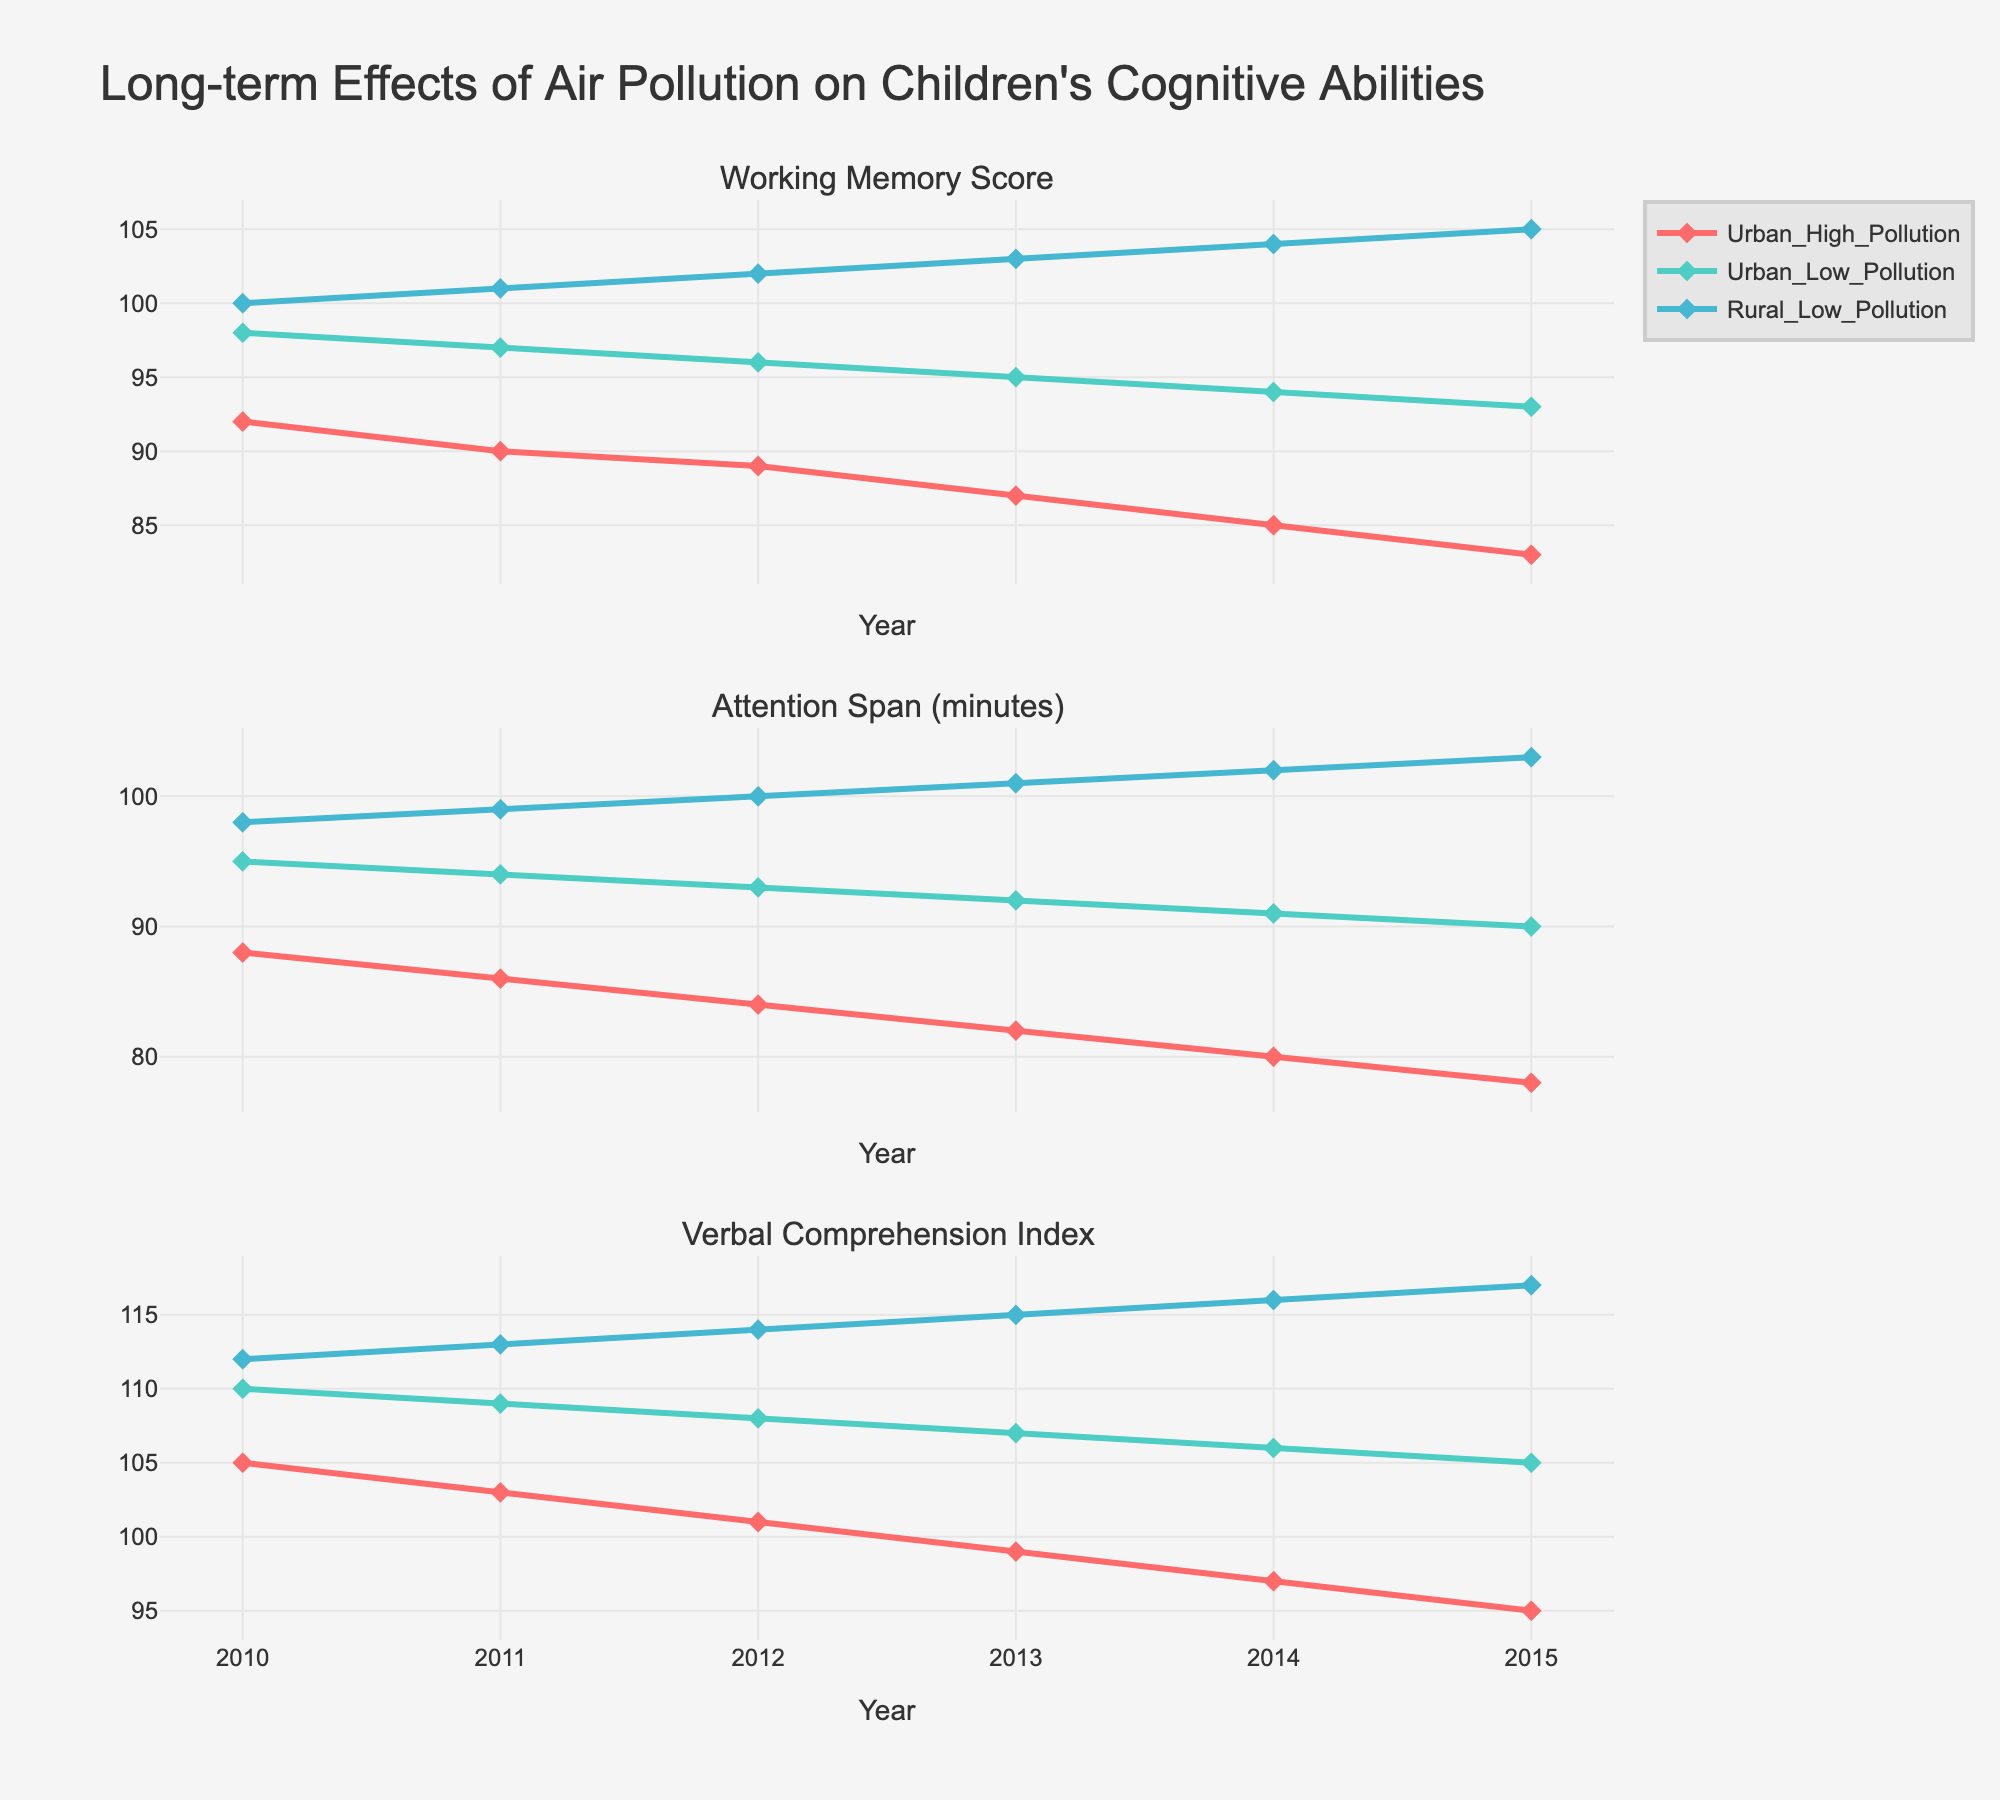What is the difference in the Working Memory Score for Urban High Pollution and Rural Low Pollution in 2010? The Working Memory Score for Urban High Pollution in 2010 is 92, and for Rural Low Pollution, it is 100. The difference is 100 - 92.
Answer: 8 Which area had a higher Attention Span score in 2013, Urban Low Pollution or Urban High Pollution? In 2013, the Attention Span score for Urban High Pollution is 82, while for Urban Low Pollution, it is 92. Urban Low Pollution has a higher score.
Answer: Urban Low Pollution What is the trend in Verbal Comprehension Index for Rural Low Pollution from 2010 to 2015? For Rural Low Pollution, the Verbal Comprehension Index from 2010 to 2015 shows: 112, 113, 114, 115, 116, and 117. This indicates a consistent upward trend.
Answer: Increasing How does the Attention Span score change from 2010 to 2015 for Urban High Pollution and Urban Low Pollution? For Urban High Pollution, the Attention Span score decreases from 88 in 2010 to 78 in 2015. For Urban Low Pollution, it decreases from 95 in 2010 to 90 in 2015. Both show a downward trend.
Answer: Decreases Which cognitive test type shows the highest average score across all years and groups? To find the highest average score, calculate the average for each test type. Working Memory scores are 92, 98, 100 etc., Attention Span are 88, 95, 98, etc., Verbal Comprehension are 105, 110, 112 etc. Verbal Comprehension generally has higher scores.
Answer: Verbal Comprehension Index In which year did the Rural Low Pollution group's Working Memory Score increase the most compared to the previous year? Calculate the yearly increase for Rural Low Pollution Working Memory Score: 101 - 100 (2011), 102 - 101 (2012), 103 - 102 (2013), 104 - 103 (2014), and 105 - 104 (2015). The increase is consistently by 1 each year.
Answer: No year Are the trends in Verbal Comprehension Index for Urban Low Pollution and Rural Low Pollution different? In Urban Low Pollution, the Verbal Comprehension Index decreases from 110 in 2010 to 105 in 2015. In Rural Low Pollution, it increases steadily from 112 in 2010 to 117 in 2015. The trends are opposite.
Answer: Yes What is the overall change in the Attention Span score from 2010 to 2015 for all areas combined? Sum the 2010 scores for all areas (88 + 95 + 98) = 281 and the 2015 scores (78 + 90 + 103) = 271. The overall change is 271 - 281.
Answer: -10 